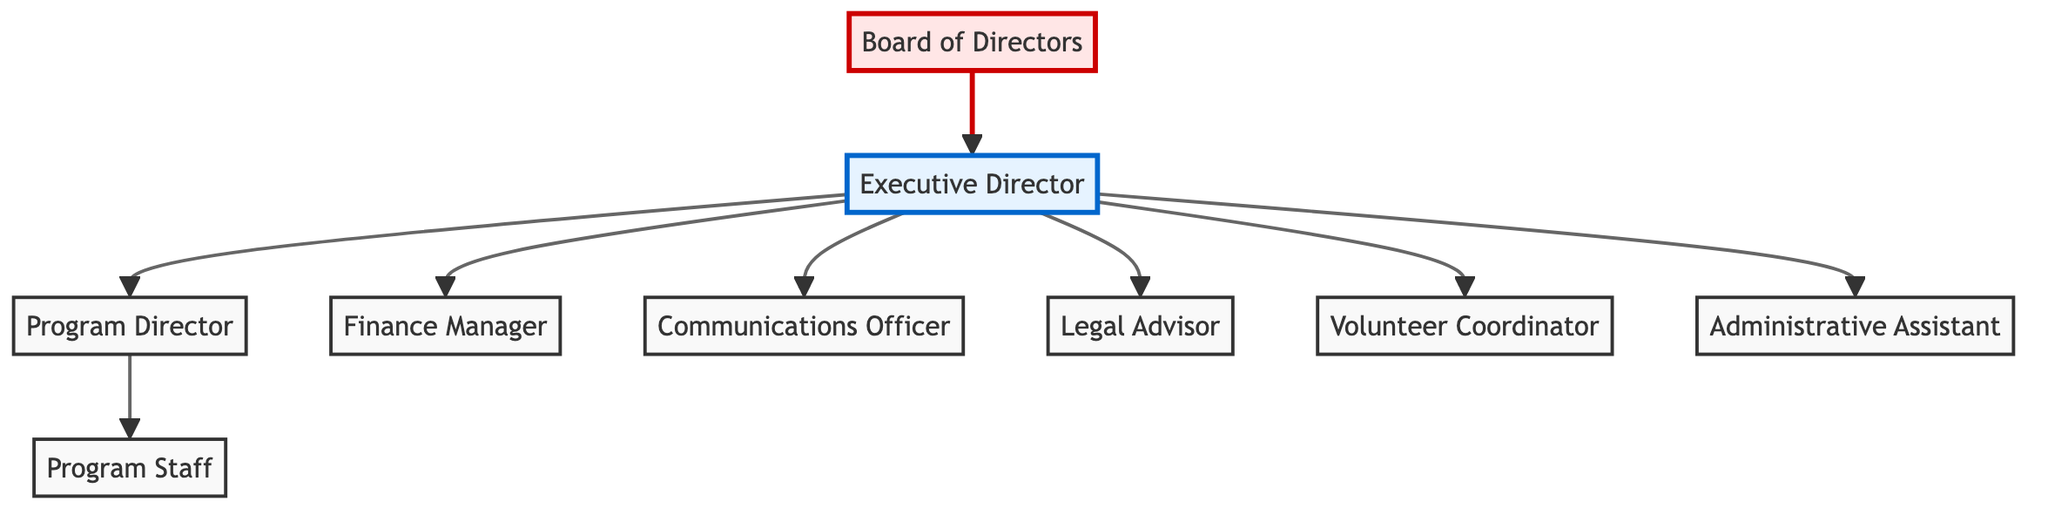What is the highest position in the organizational structure? The highest position is the Executive Director, as it is directly below the Board of Directors and oversees all other positions in the organization.
Answer: Executive Director How many positions report directly to the Executive Director? Looking at the diagram, the Executive Director has seven direct reports, which include the Program Director, Finance Manager, Communications Officer, Legal Advisor, Volunteer Coordinator, Administrative Assistant, and Program Staff.
Answer: Seven What role is responsible for the financial management of the NGO? The Finance Manager is the designated role responsible for overseeing finances within the organizational structure, reporting directly to the Executive Director.
Answer: Finance Manager Which position is related to volunteer management? The Volunteer Coordinator is specifically tasked with managing volunteers in the organization, as indicated in the diagram by its connection to the Executive Director.
Answer: Volunteer Coordinator How many levels are there in the organizational hierarchy, including the Board of Directors? The diagram shows 3 levels: the Board of Directors at the top, the Executive Director in the middle, and the various managerial positions and staff below.
Answer: Three Who does the Program Director oversee? The Program Director oversees the Program Staff, as shown by the directional line in the diagram pointing from the Program Director to the Program Staff.
Answer: Program Staff What distinguishes the Board of Directors from the Executive Director? The Board of Directors functions at the governance level, while the Executive Director plays an operational role in executing the directives passed down from the Board.
Answer: Governance vs. Operational List one role that reports to the Program Director. The Program Staff reports to the Program Director, as indicated in the structure where the Program Director is connected to the Program Staff node.
Answer: Program Staff Which role is focused on legal matters? The role responsible for legal matters within the NGO's structure is the Legal Advisor, as denoted in the diagram.
Answer: Legal Advisor 